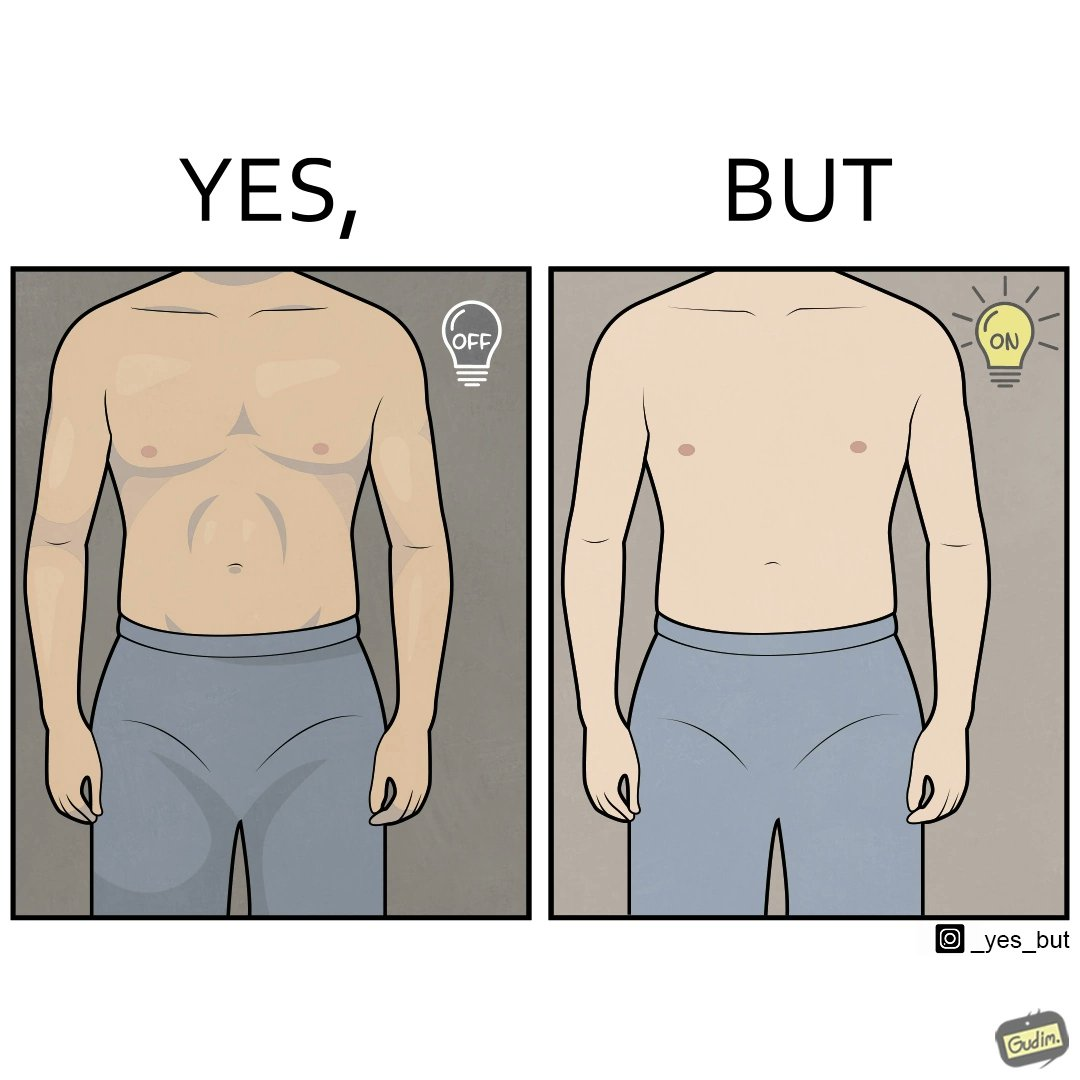Provide a description of this image. The images are funny because it shows the same body in two different lighting conditions, one where it appears muscular and one where it does not appear so. It shows how we can make the same thing appear appealing to others without it being as appealing in real life 